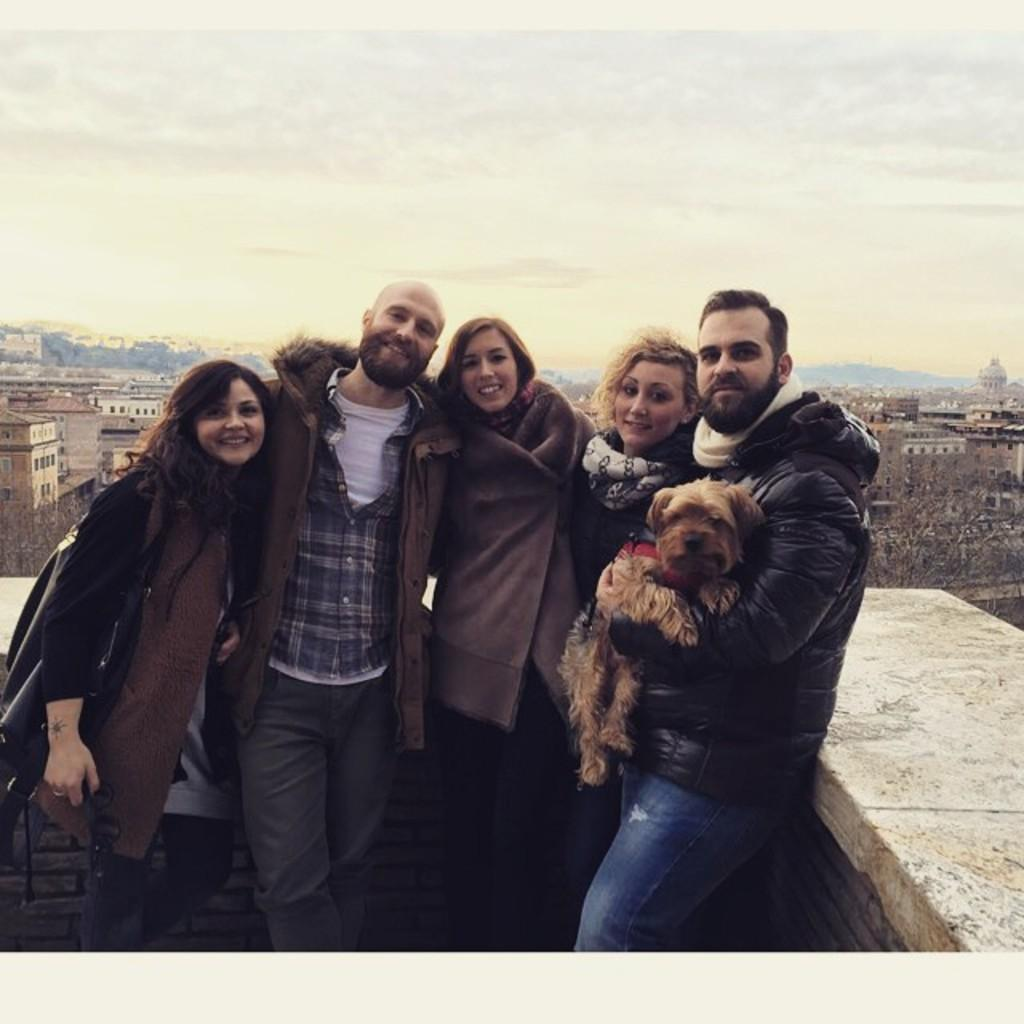What type of structures can be seen in the image? There are buildings in the image. What else can be seen in the image besides buildings? There are trees and people standing in the image. Can you describe the interaction between a man and an animal in the image? A man is holding a dog in the image. How would you describe the weather based on the image? The sky is cloudy in the image. What type of rings does the uncle wear in the image? There is no uncle or rings present in the image. 